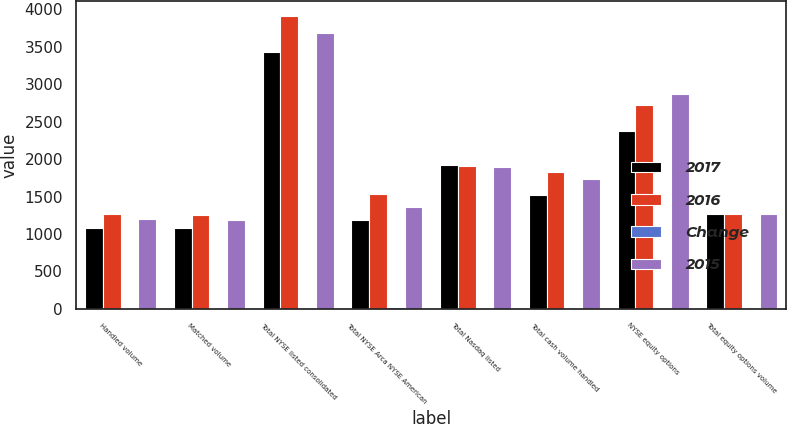Convert chart. <chart><loc_0><loc_0><loc_500><loc_500><stacked_bar_chart><ecel><fcel>Handled volume<fcel>Matched volume<fcel>Total NYSE listed consolidated<fcel>Total NYSE Arca NYSE American<fcel>Total Nasdaq listed<fcel>Total cash volume handled<fcel>NYSE equity options<fcel>Total equity options volume<nl><fcel>2017<fcel>1086<fcel>1077<fcel>3434<fcel>1188<fcel>1921<fcel>1521<fcel>2375<fcel>1269<nl><fcel>2016<fcel>1269<fcel>1256<fcel>3918<fcel>1536<fcel>1907<fcel>1828<fcel>2719<fcel>1269<nl><fcel>Change<fcel>14<fcel>14<fcel>12<fcel>23<fcel>1<fcel>17<fcel>13<fcel>2<nl><fcel>2015<fcel>1203<fcel>1185<fcel>3685<fcel>1355<fcel>1894<fcel>1730<fcel>2867<fcel>1269<nl></chart> 